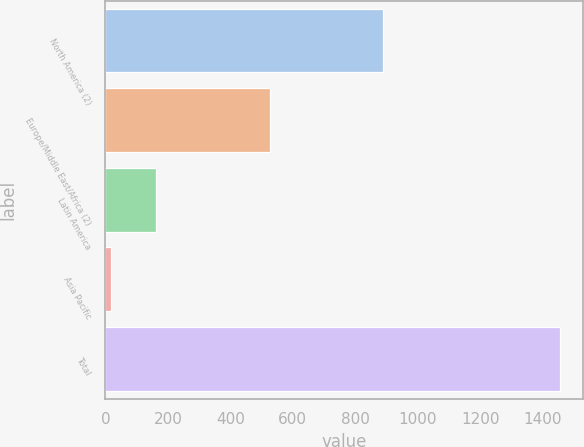Convert chart to OTSL. <chart><loc_0><loc_0><loc_500><loc_500><bar_chart><fcel>North America (2)<fcel>Europe/Middle East/Africa (2)<fcel>Latin America<fcel>Asia Pacific<fcel>Total<nl><fcel>888.7<fcel>526.6<fcel>162.72<fcel>18.9<fcel>1457.1<nl></chart> 